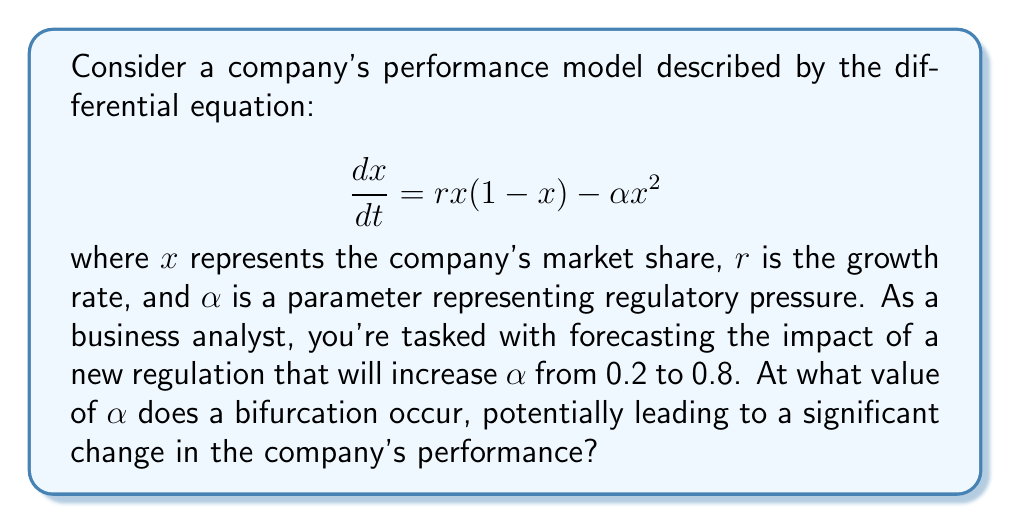Solve this math problem. To solve this problem, we need to follow these steps:

1) First, we need to find the equilibrium points of the system. These are the points where $\frac{dx}{dt} = 0$:

   $$rx(1-x) - \alpha x^2 = 0$$

2) Factoring out $x$:

   $$x(r(1-x) - \alpha x) = 0$$

3) This gives us two solutions: $x = 0$ and $r(1-x) - \alpha x = 0$

4) Solving the second equation:

   $$r - rx - \alpha x = 0$$
   $$(r - \alpha)x = r$$
   $$x = \frac{r}{r - \alpha}$$

5) For a bifurcation to occur, this equilibrium point should coincide with $x = 0$. This happens when the denominator becomes zero:

   $$r - \alpha = 0$$
   $$\alpha = r$$

6) Therefore, the bifurcation occurs when $\alpha$ equals $r$.

7) In this case, we're not given the value of $r$. However, we can infer it from the initial condition of $\alpha = 0.2$. Since the company was stable before the regulatory change, we can assume that $r > 0.2$.

8) The new value of $\alpha$ is 0.8, which is greater than the initial value. If $r < 0.8$, a bifurcation will occur as $\alpha$ increases from 0.2 to 0.8.

9) Therefore, the bifurcation occurs at $\alpha = r$, where $r$ is between 0.2 and 0.8.

This bifurcation represents a critical point where the company's performance could dramatically change, potentially leading to market exit if $\alpha > r$.
Answer: $\alpha = r$, where $0.2 < r < 0.8$ 